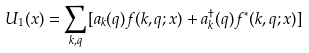Convert formula to latex. <formula><loc_0><loc_0><loc_500><loc_500>U _ { 1 } ( { x } ) = \sum _ { { k } , { q } } [ a _ { k } ( { q } ) f ( { k } , { q } ; { x } ) + a ^ { \dagger } _ { k } ( { q } ) f ^ { * } ( { k } , { q } ; { x } ) ]</formula> 